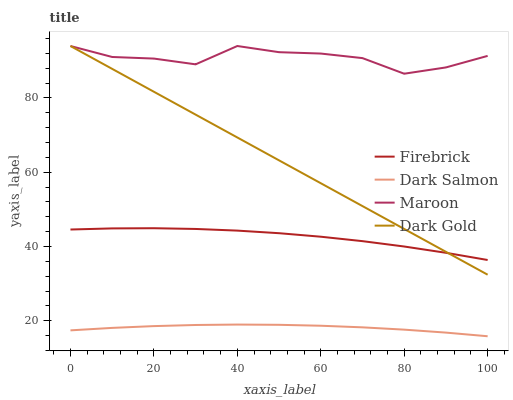Does Dark Salmon have the minimum area under the curve?
Answer yes or no. Yes. Does Maroon have the maximum area under the curve?
Answer yes or no. Yes. Does Maroon have the minimum area under the curve?
Answer yes or no. No. Does Dark Salmon have the maximum area under the curve?
Answer yes or no. No. Is Dark Gold the smoothest?
Answer yes or no. Yes. Is Maroon the roughest?
Answer yes or no. Yes. Is Dark Salmon the smoothest?
Answer yes or no. No. Is Dark Salmon the roughest?
Answer yes or no. No. Does Dark Salmon have the lowest value?
Answer yes or no. Yes. Does Maroon have the lowest value?
Answer yes or no. No. Does Dark Gold have the highest value?
Answer yes or no. Yes. Does Dark Salmon have the highest value?
Answer yes or no. No. Is Dark Salmon less than Firebrick?
Answer yes or no. Yes. Is Maroon greater than Firebrick?
Answer yes or no. Yes. Does Maroon intersect Dark Gold?
Answer yes or no. Yes. Is Maroon less than Dark Gold?
Answer yes or no. No. Is Maroon greater than Dark Gold?
Answer yes or no. No. Does Dark Salmon intersect Firebrick?
Answer yes or no. No. 